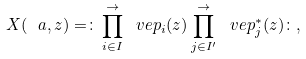Convert formula to latex. <formula><loc_0><loc_0><loc_500><loc_500>X ( \ a , z ) = \colon \prod _ { i \in I } ^ { \rightarrow } \ v e p _ { i } ( z ) \prod _ { j \in I ^ { \prime } } ^ { \rightarrow } \ v e p _ { j } ^ { * } ( z ) \colon ,</formula> 